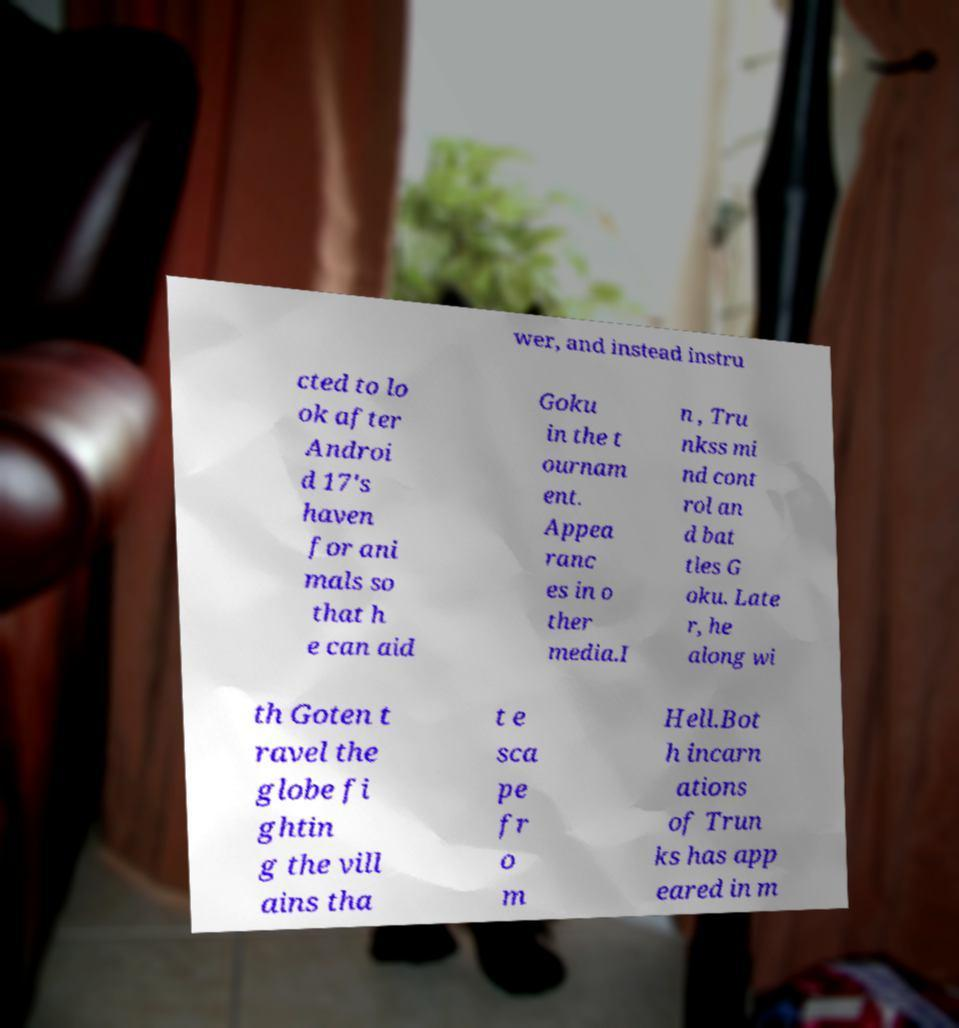What messages or text are displayed in this image? I need them in a readable, typed format. wer, and instead instru cted to lo ok after Androi d 17's haven for ani mals so that h e can aid Goku in the t ournam ent. Appea ranc es in o ther media.I n , Tru nkss mi nd cont rol an d bat tles G oku. Late r, he along wi th Goten t ravel the globe fi ghtin g the vill ains tha t e sca pe fr o m Hell.Bot h incarn ations of Trun ks has app eared in m 